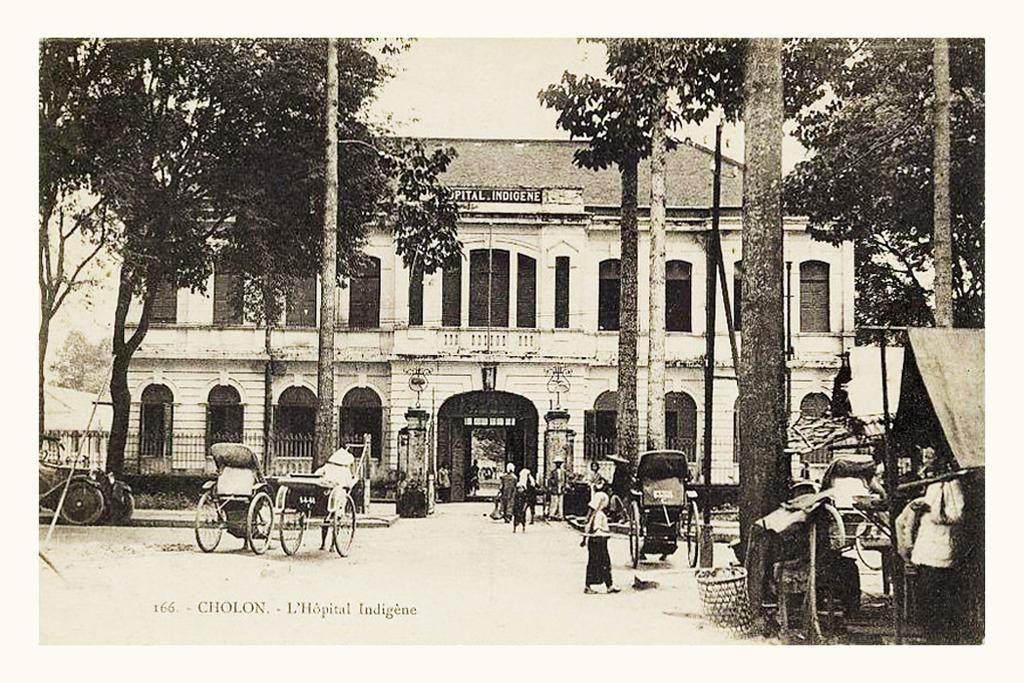In one or two sentences, can you explain what this image depicts? This is a old picture , in the picture I can see the building and persons walking on the road and I can see a tent on the right side and the sky, poles and trees and vehicles. 